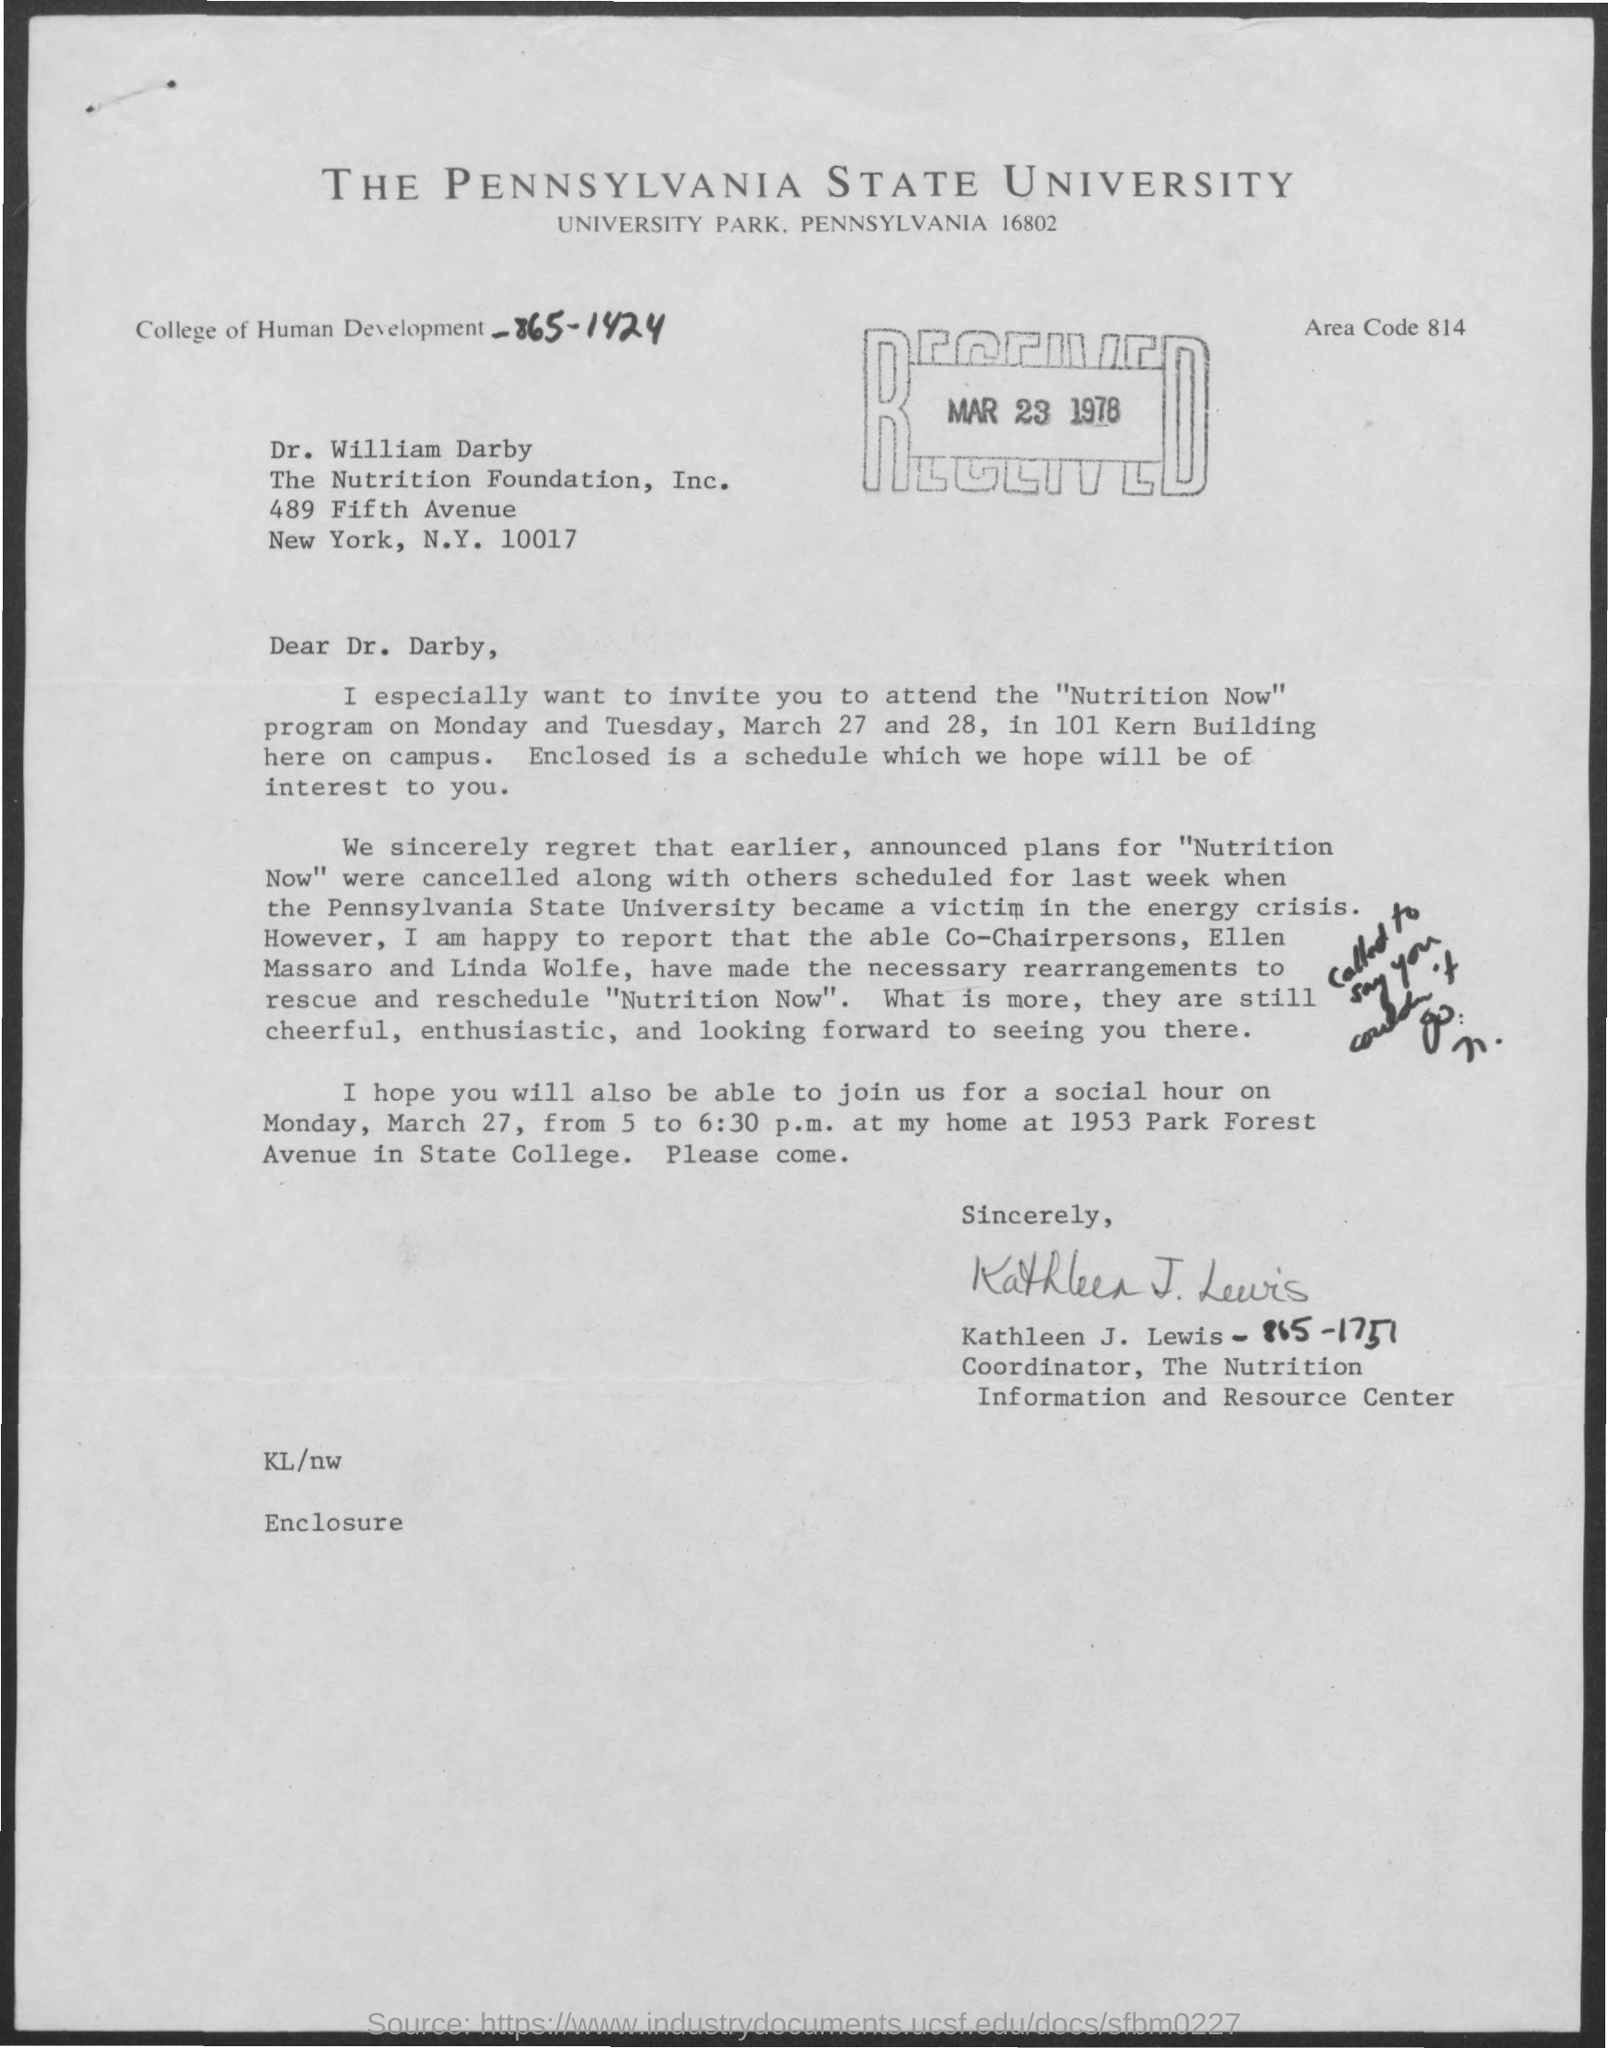When is the document dated?
Offer a terse response. Mar 23 1978. What is the Area Code?
Offer a very short reply. 814. To whom is the letter addressed?
Ensure brevity in your answer.  Dr. William Darby. What is the program name mentioned?
Ensure brevity in your answer.  Nutrition Now. When is the program going to be held?
Your response must be concise. Monday and Tuesday, March 27 and 28. Who is the sender?
Offer a very short reply. Kathleen J. Lewis - 865-1751. Kathleen is the coordinator of which institution?
Your answer should be compact. The Nutrition Information and Resource Center. 